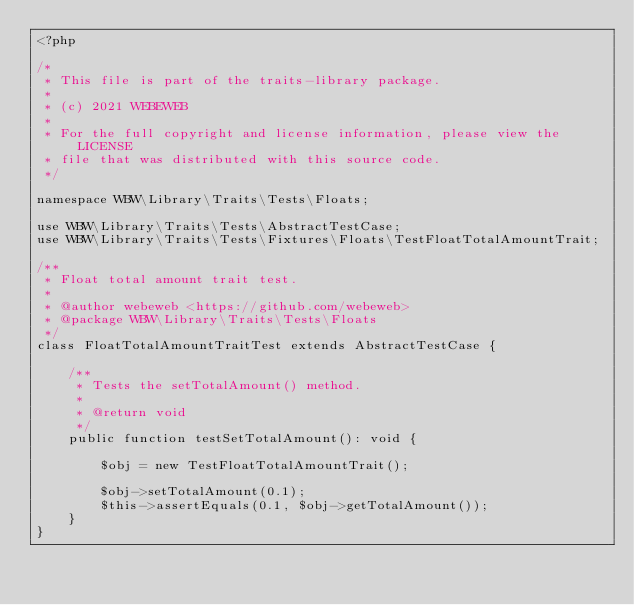<code> <loc_0><loc_0><loc_500><loc_500><_PHP_><?php

/*
 * This file is part of the traits-library package.
 *
 * (c) 2021 WEBEWEB
 *
 * For the full copyright and license information, please view the LICENSE
 * file that was distributed with this source code.
 */

namespace WBW\Library\Traits\Tests\Floats;

use WBW\Library\Traits\Tests\AbstractTestCase;
use WBW\Library\Traits\Tests\Fixtures\Floats\TestFloatTotalAmountTrait;

/**
 * Float total amount trait test.
 *
 * @author webeweb <https://github.com/webeweb>
 * @package WBW\Library\Traits\Tests\Floats
 */
class FloatTotalAmountTraitTest extends AbstractTestCase {

    /**
     * Tests the setTotalAmount() method.
     *
     * @return void
     */
    public function testSetTotalAmount(): void {

        $obj = new TestFloatTotalAmountTrait();

        $obj->setTotalAmount(0.1);
        $this->assertEquals(0.1, $obj->getTotalAmount());
    }
}</code> 